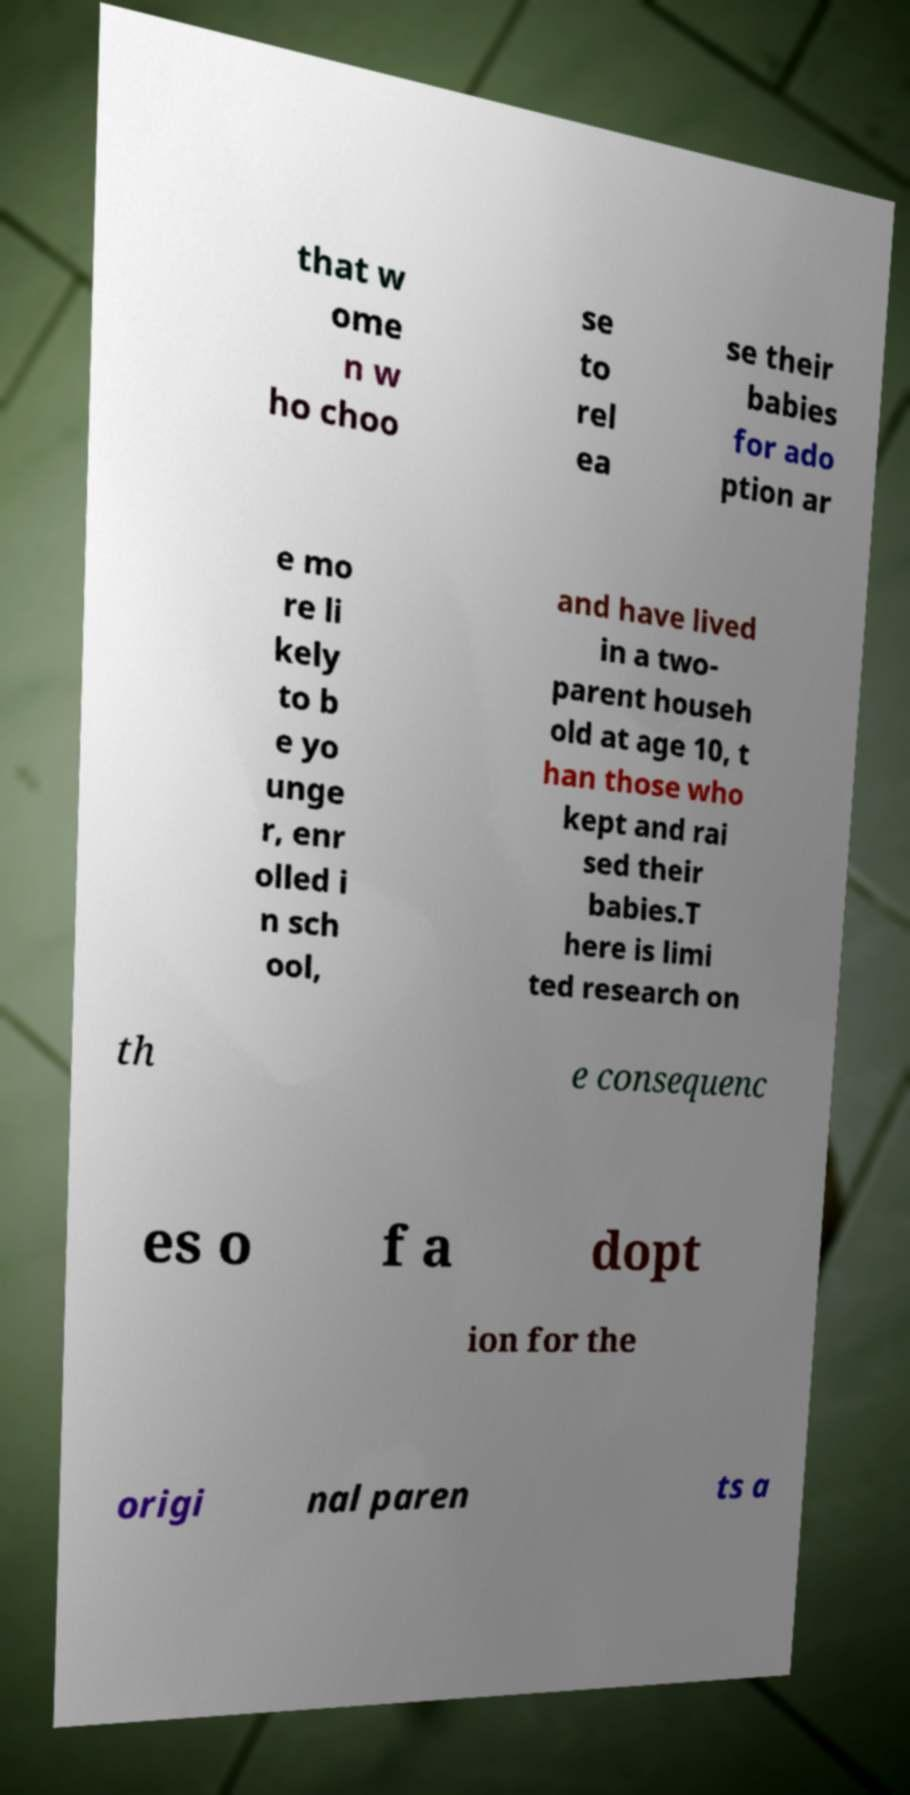Can you read and provide the text displayed in the image?This photo seems to have some interesting text. Can you extract and type it out for me? that w ome n w ho choo se to rel ea se their babies for ado ption ar e mo re li kely to b e yo unge r, enr olled i n sch ool, and have lived in a two- parent househ old at age 10, t han those who kept and rai sed their babies.T here is limi ted research on th e consequenc es o f a dopt ion for the origi nal paren ts a 